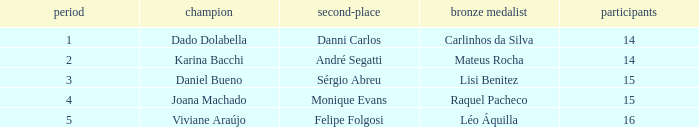Can you parse all the data within this table? {'header': ['period', 'champion', 'second-place', 'bronze medalist', 'participants'], 'rows': [['1', 'Dado Dolabella', 'Danni Carlos', 'Carlinhos da Silva', '14'], ['2', 'Karina Bacchi', 'André Segatti', 'Mateus Rocha', '14'], ['3', 'Daniel Bueno', 'Sérgio Abreu', 'Lisi Benitez', '15'], ['4', 'Joana Machado', 'Monique Evans', 'Raquel Pacheco', '15'], ['5', 'Viviane Araújo', 'Felipe Folgosi', 'Léo Áquilla', '16']]} In what season was the winner Dado Dolabella? 1.0. 